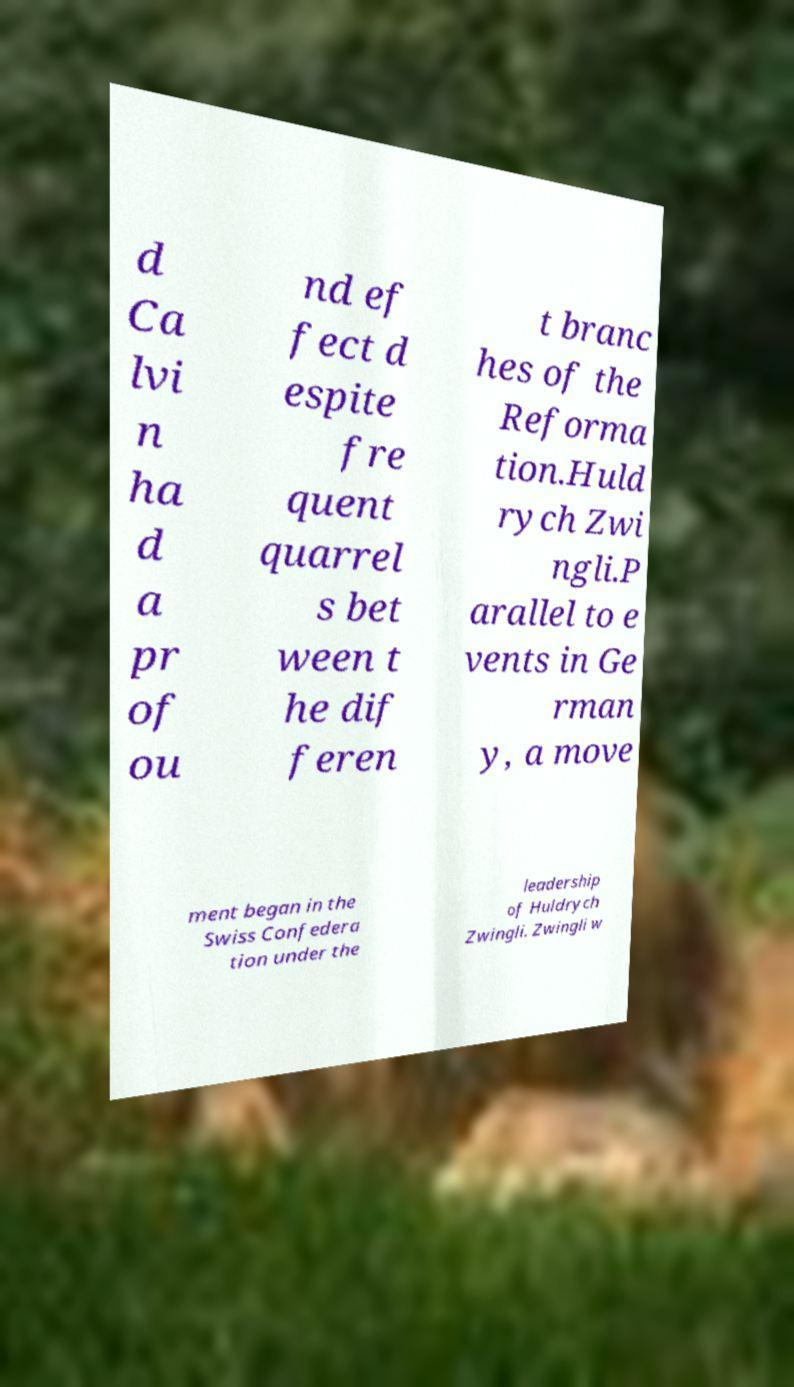What messages or text are displayed in this image? I need them in a readable, typed format. d Ca lvi n ha d a pr of ou nd ef fect d espite fre quent quarrel s bet ween t he dif feren t branc hes of the Reforma tion.Huld rych Zwi ngli.P arallel to e vents in Ge rman y, a move ment began in the Swiss Confedera tion under the leadership of Huldrych Zwingli. Zwingli w 